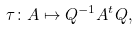<formula> <loc_0><loc_0><loc_500><loc_500>\tau \colon A \mapsto Q ^ { - 1 } A ^ { t } Q ,</formula> 